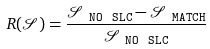<formula> <loc_0><loc_0><loc_500><loc_500>R ( \mathcal { S } ) = \frac { \mathcal { S } _ { \ { \tt N O \ S L C } } - \mathcal { S } _ { \ { \tt M A T C H } } } { \mathcal { S } _ { \ { \tt N O \ S L C } } }</formula> 